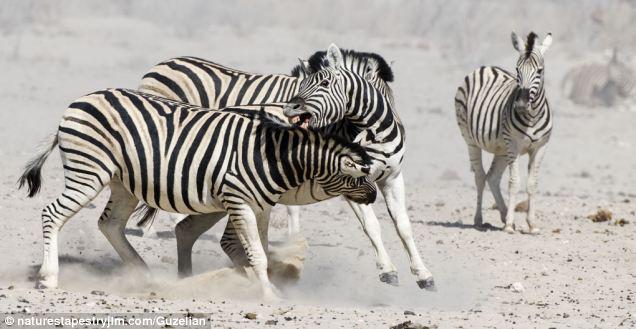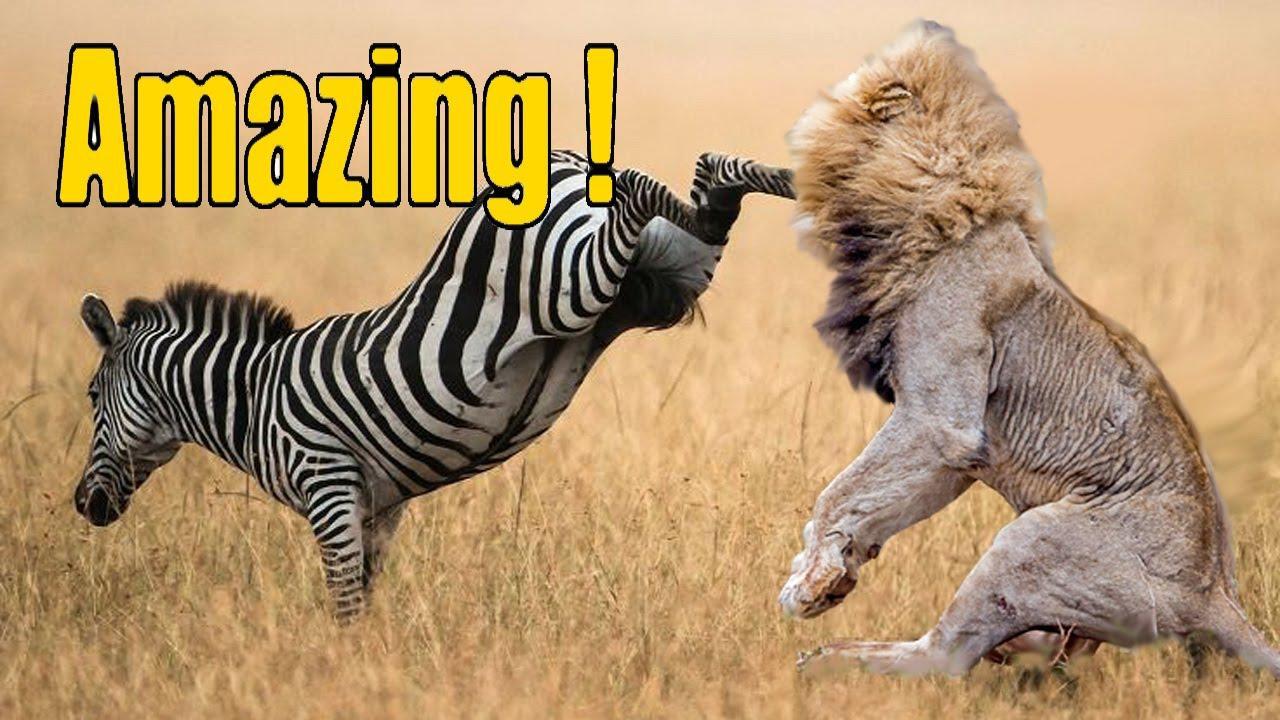The first image is the image on the left, the second image is the image on the right. Examine the images to the left and right. Is the description "One of the images shows a zebra in close contact with a mammal of another species." accurate? Answer yes or no. Yes. 